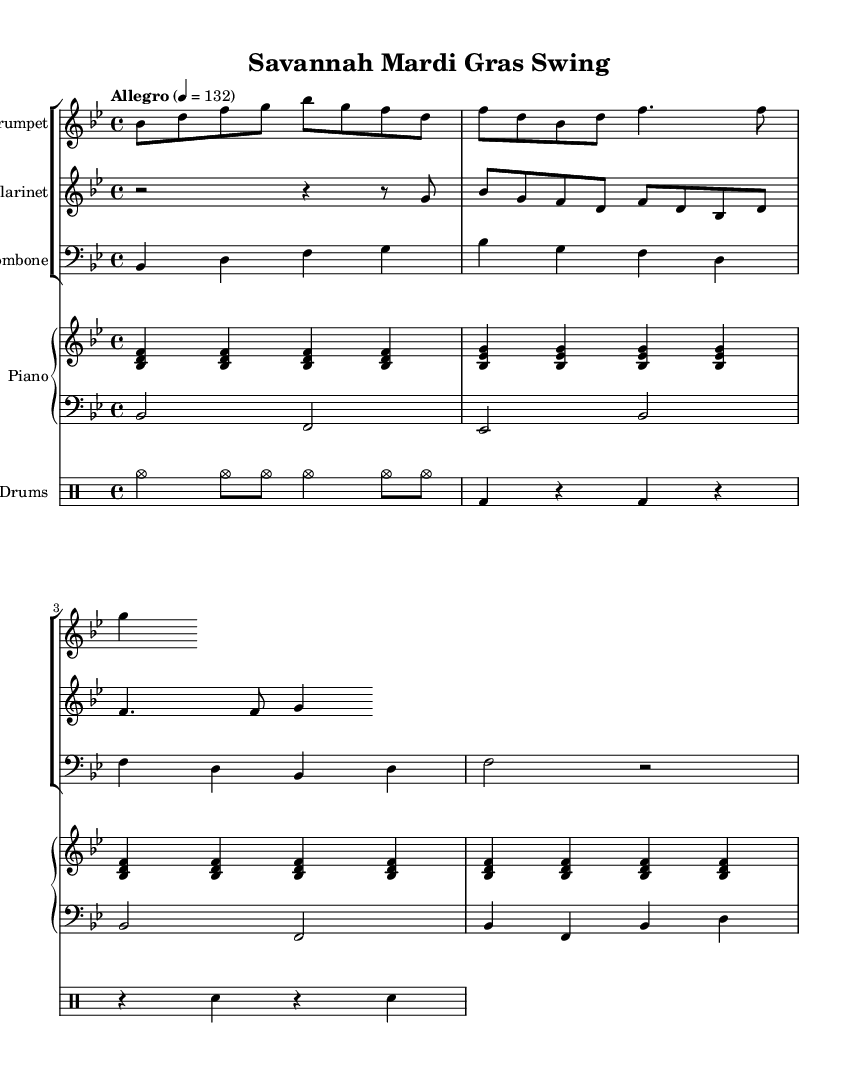What is the key signature of this music? The key signature is indicated by the sharp or flat symbols at the beginning of the staff. In this case, it shows two flats (B♭ and E♭), identifying the key as B♭ major.
Answer: B♭ major What is the time signature of this music? The time signature is found at the beginning of the piece, represented by two numbers stacked vertically. Here, it shows "4/4," meaning there are four beats in each measure, and the quarter note gets one beat.
Answer: 4/4 What is the tempo marking for this piece? The tempo marking is usually written above the staff, indicating how fast the piece should be played. It states "Allegro" and the tempo is set to 132 beats per minute.
Answer: Allegro 132 Which instrument plays in the bass clef? The instrument playing in the bass clef can be identified by looking at the clef symbols at the beginning of the staffs. The bass staff is for the trombone and the bass part, primarily indicating lower pitch sounds.
Answer: Trombone and bass How many measures does the piano part have before the next line? To find the number of measures in the piano part before it continues, count the vertical lines separating the measures in the piano music. There are 8 measures laid out before the next line starts.
Answer: 8 What is unique about the rhythm in the drum part? The rhythm unique to the drum part can be analyzed by looking at the notation used; it predominantly features cymbal and bass drum patterns that emphasize a swing feel typical in jazz, contrasting with straighter rhythms. This creates a lively, upbeat feel suitable for Mardi Gras.
Answer: Swing What mood does the overall composition evoke? To determine the mood, consider both the tempo marking and the style of the melody being played. The upbeat tempo (Allegro) combined with a jazzy swing rhythm creates a lively, celebratory atmosphere, reminiscent of the festive spirit of Mardi Gras.
Answer: Upbeat and celebratory 